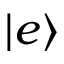<formula> <loc_0><loc_0><loc_500><loc_500>| e \rangle</formula> 